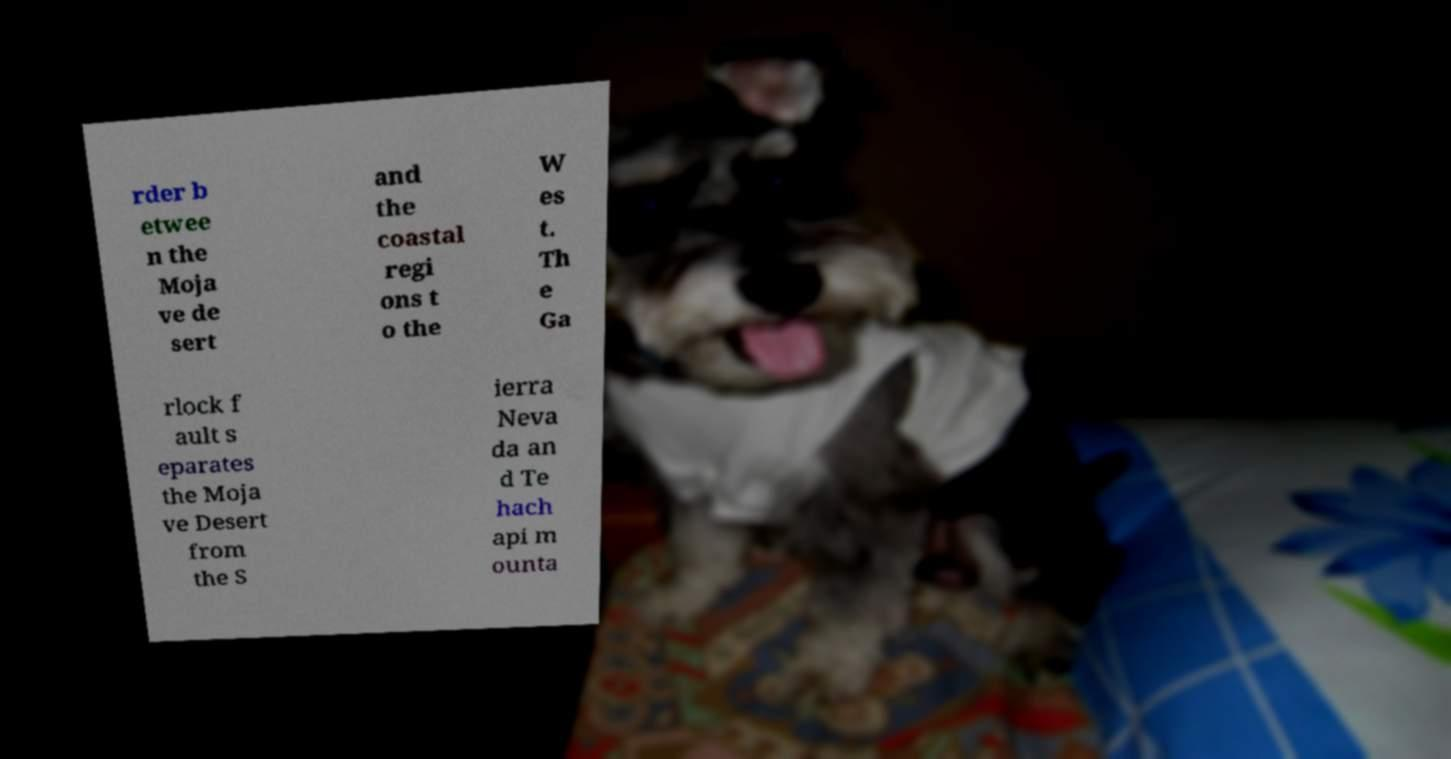Please identify and transcribe the text found in this image. rder b etwee n the Moja ve de sert and the coastal regi ons t o the W es t. Th e Ga rlock f ault s eparates the Moja ve Desert from the S ierra Neva da an d Te hach api m ounta 